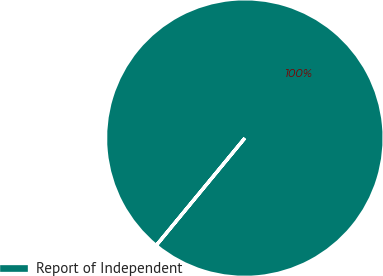Convert chart to OTSL. <chart><loc_0><loc_0><loc_500><loc_500><pie_chart><fcel>Report of Independent<nl><fcel>100.0%<nl></chart> 